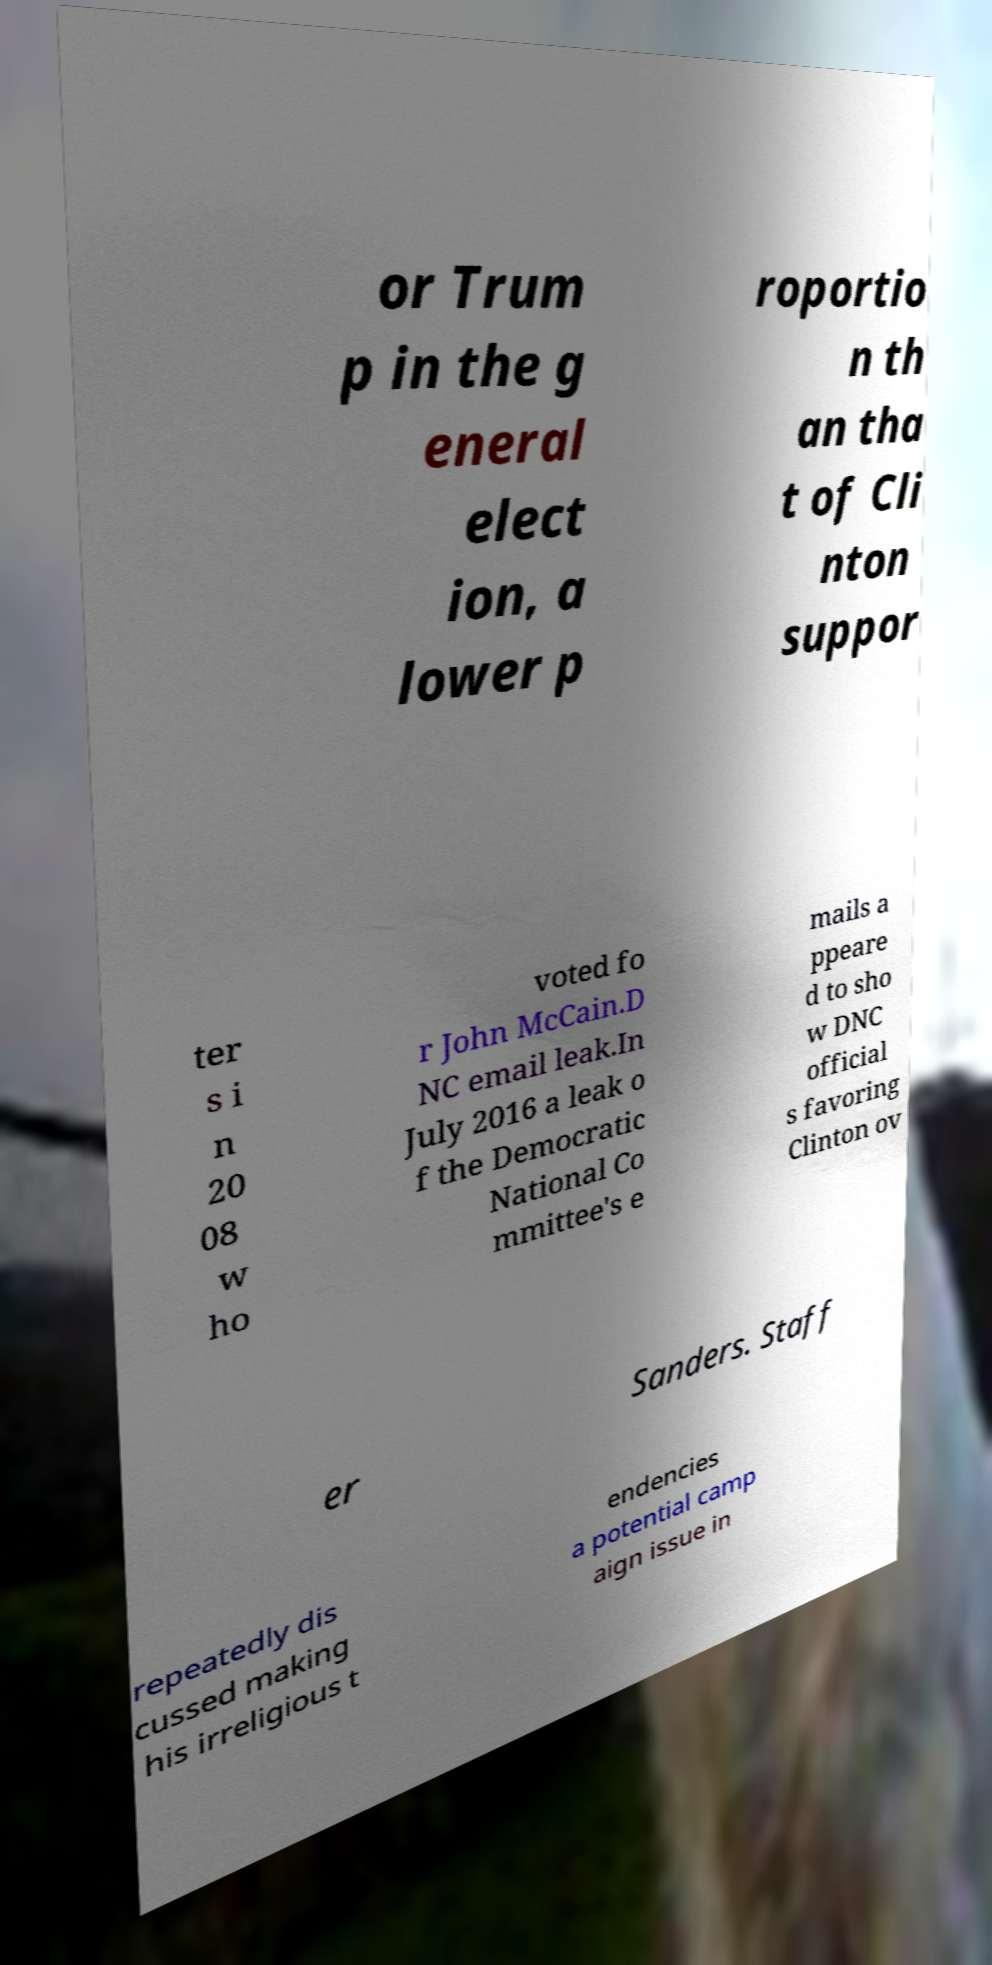Please read and relay the text visible in this image. What does it say? or Trum p in the g eneral elect ion, a lower p roportio n th an tha t of Cli nton suppor ter s i n 20 08 w ho voted fo r John McCain.D NC email leak.In July 2016 a leak o f the Democratic National Co mmittee's e mails a ppeare d to sho w DNC official s favoring Clinton ov er Sanders. Staff repeatedly dis cussed making his irreligious t endencies a potential camp aign issue in 